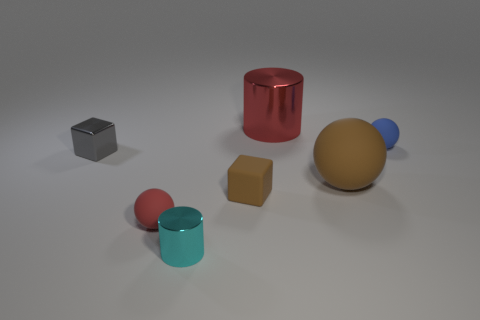Are there fewer brown matte objects that are behind the gray cube than green rubber cylinders?
Give a very brief answer. No. How many rubber objects are there?
Offer a very short reply. 4. There is a big metal thing; does it have the same shape as the large thing on the right side of the big cylinder?
Provide a succinct answer. No. Is the number of small brown cubes on the left side of the small cyan cylinder less than the number of tiny matte balls behind the small matte cube?
Offer a very short reply. Yes. Are there any other things that have the same shape as the small red object?
Your response must be concise. Yes. Does the tiny red thing have the same shape as the big red shiny thing?
Provide a succinct answer. No. Is there any other thing that is made of the same material as the gray block?
Offer a very short reply. Yes. The blue ball has what size?
Provide a succinct answer. Small. What is the color of the tiny thing that is both to the right of the tiny cyan object and on the left side of the red cylinder?
Ensure brevity in your answer.  Brown. Are there more tiny green metal cylinders than small gray objects?
Offer a terse response. No. 